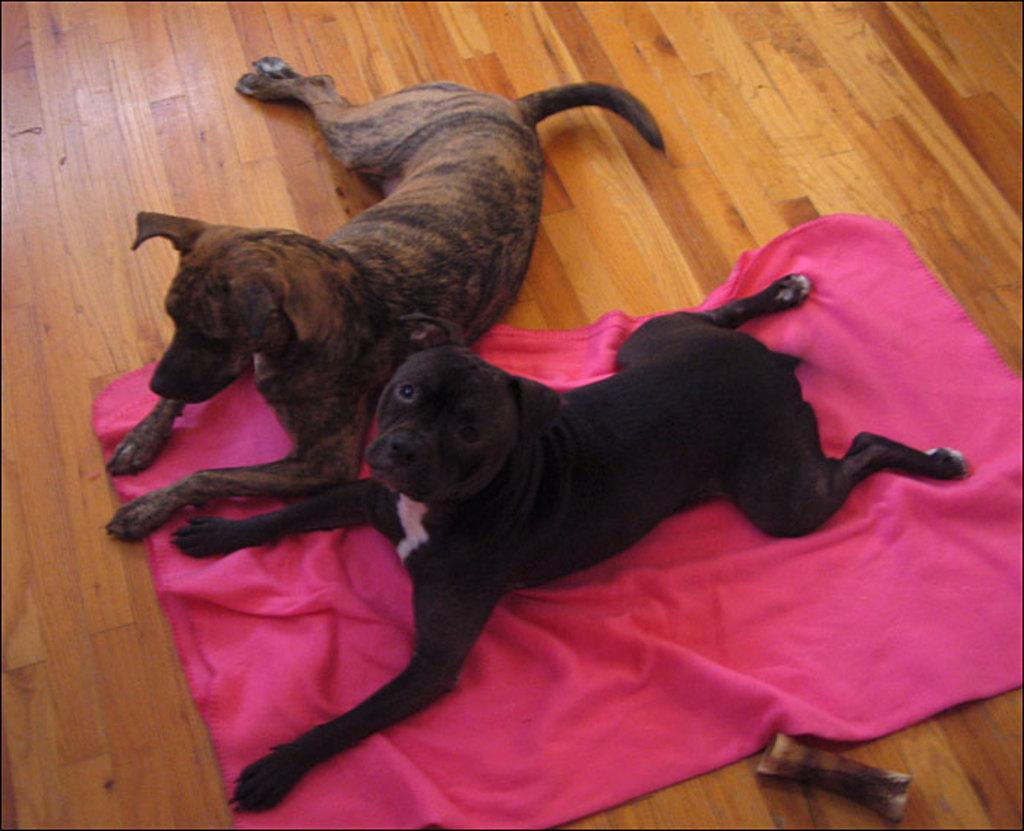How many dogs are present in the image? There are two dogs in the image. Where are the dogs located? The dogs are on the floor. What else can be seen in the image besides the dogs? There is a blanket in the image. What is the mass of the star in the image? There is no star present in the image, so it is not possible to determine its mass. 